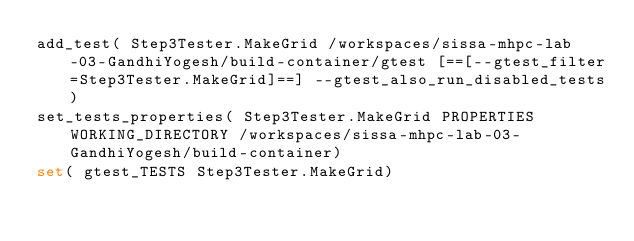Convert code to text. <code><loc_0><loc_0><loc_500><loc_500><_CMake_>add_test( Step3Tester.MakeGrid /workspaces/sissa-mhpc-lab-03-GandhiYogesh/build-container/gtest [==[--gtest_filter=Step3Tester.MakeGrid]==] --gtest_also_run_disabled_tests)
set_tests_properties( Step3Tester.MakeGrid PROPERTIES WORKING_DIRECTORY /workspaces/sissa-mhpc-lab-03-GandhiYogesh/build-container)
set( gtest_TESTS Step3Tester.MakeGrid)
</code> 